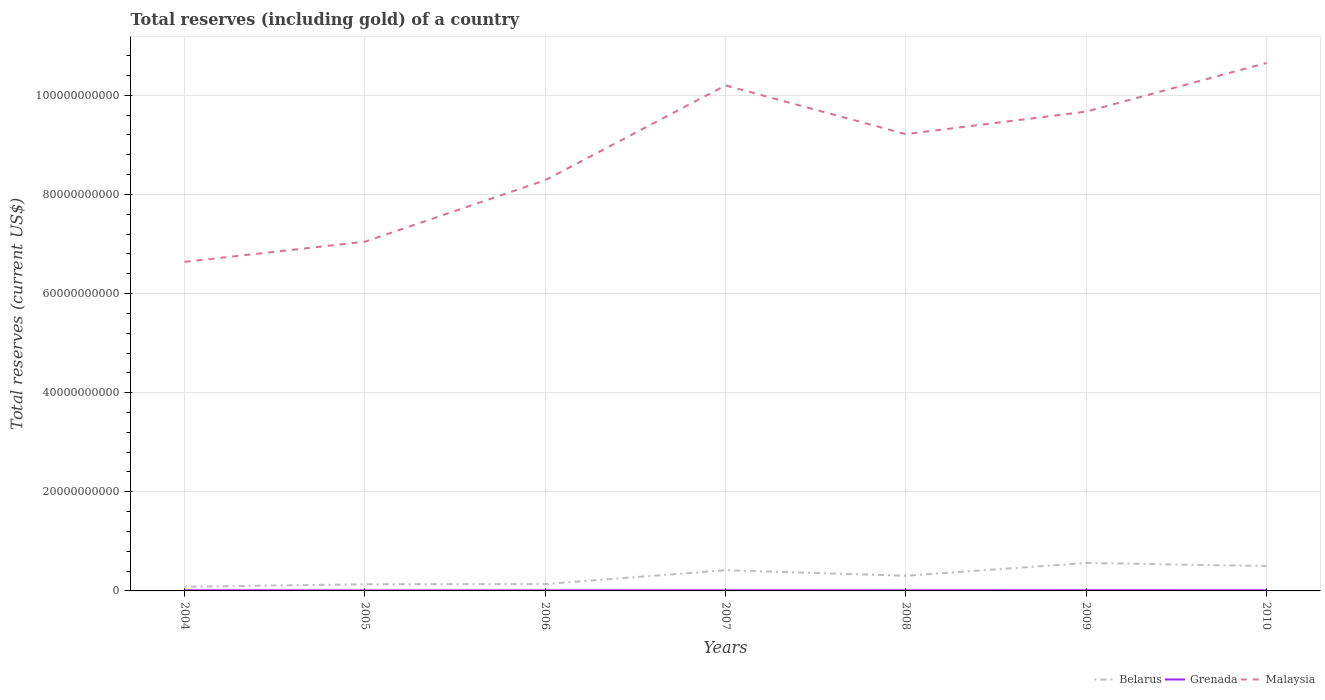How many different coloured lines are there?
Offer a terse response. 3. Across all years, what is the maximum total reserves (including gold) in Malaysia?
Your answer should be compact. 6.64e+1. What is the total total reserves (including gold) in Grenada in the graph?
Make the answer very short. -1.38e+07. What is the difference between the highest and the second highest total reserves (including gold) in Belarus?
Provide a short and direct response. 4.80e+09. What is the difference between the highest and the lowest total reserves (including gold) in Grenada?
Offer a terse response. 3. What is the difference between two consecutive major ticks on the Y-axis?
Keep it short and to the point. 2.00e+1. Does the graph contain grids?
Provide a short and direct response. Yes. How are the legend labels stacked?
Provide a short and direct response. Horizontal. What is the title of the graph?
Your response must be concise. Total reserves (including gold) of a country. Does "Paraguay" appear as one of the legend labels in the graph?
Your answer should be compact. No. What is the label or title of the Y-axis?
Your answer should be very brief. Total reserves (current US$). What is the Total reserves (current US$) of Belarus in 2004?
Make the answer very short. 8.37e+08. What is the Total reserves (current US$) of Grenada in 2004?
Ensure brevity in your answer.  1.22e+08. What is the Total reserves (current US$) in Malaysia in 2004?
Offer a terse response. 6.64e+1. What is the Total reserves (current US$) of Belarus in 2005?
Keep it short and to the point. 1.34e+09. What is the Total reserves (current US$) of Grenada in 2005?
Offer a terse response. 9.43e+07. What is the Total reserves (current US$) in Malaysia in 2005?
Provide a succinct answer. 7.05e+1. What is the Total reserves (current US$) in Belarus in 2006?
Give a very brief answer. 1.39e+09. What is the Total reserves (current US$) of Grenada in 2006?
Provide a succinct answer. 1.00e+08. What is the Total reserves (current US$) in Malaysia in 2006?
Your answer should be very brief. 8.29e+1. What is the Total reserves (current US$) in Belarus in 2007?
Offer a very short reply. 4.18e+09. What is the Total reserves (current US$) of Grenada in 2007?
Offer a terse response. 1.11e+08. What is the Total reserves (current US$) in Malaysia in 2007?
Make the answer very short. 1.02e+11. What is the Total reserves (current US$) of Belarus in 2008?
Give a very brief answer. 3.06e+09. What is the Total reserves (current US$) in Grenada in 2008?
Offer a terse response. 1.05e+08. What is the Total reserves (current US$) in Malaysia in 2008?
Give a very brief answer. 9.22e+1. What is the Total reserves (current US$) of Belarus in 2009?
Make the answer very short. 5.64e+09. What is the Total reserves (current US$) of Grenada in 2009?
Make the answer very short. 1.29e+08. What is the Total reserves (current US$) of Malaysia in 2009?
Offer a very short reply. 9.67e+1. What is the Total reserves (current US$) of Belarus in 2010?
Provide a succinct answer. 5.03e+09. What is the Total reserves (current US$) in Grenada in 2010?
Provide a short and direct response. 1.19e+08. What is the Total reserves (current US$) of Malaysia in 2010?
Offer a very short reply. 1.07e+11. Across all years, what is the maximum Total reserves (current US$) in Belarus?
Your answer should be very brief. 5.64e+09. Across all years, what is the maximum Total reserves (current US$) in Grenada?
Your response must be concise. 1.29e+08. Across all years, what is the maximum Total reserves (current US$) of Malaysia?
Make the answer very short. 1.07e+11. Across all years, what is the minimum Total reserves (current US$) of Belarus?
Your response must be concise. 8.37e+08. Across all years, what is the minimum Total reserves (current US$) of Grenada?
Give a very brief answer. 9.43e+07. Across all years, what is the minimum Total reserves (current US$) of Malaysia?
Your answer should be compact. 6.64e+1. What is the total Total reserves (current US$) in Belarus in the graph?
Your answer should be compact. 2.15e+1. What is the total Total reserves (current US$) of Grenada in the graph?
Give a very brief answer. 7.80e+08. What is the total Total reserves (current US$) in Malaysia in the graph?
Offer a very short reply. 6.17e+11. What is the difference between the Total reserves (current US$) of Belarus in 2004 and that in 2005?
Your answer should be compact. -5.05e+08. What is the difference between the Total reserves (current US$) in Grenada in 2004 and that in 2005?
Offer a very short reply. 2.75e+07. What is the difference between the Total reserves (current US$) of Malaysia in 2004 and that in 2005?
Provide a succinct answer. -4.06e+09. What is the difference between the Total reserves (current US$) of Belarus in 2004 and that in 2006?
Offer a very short reply. -5.49e+08. What is the difference between the Total reserves (current US$) in Grenada in 2004 and that in 2006?
Make the answer very short. 2.18e+07. What is the difference between the Total reserves (current US$) of Malaysia in 2004 and that in 2006?
Ensure brevity in your answer.  -1.65e+1. What is the difference between the Total reserves (current US$) of Belarus in 2004 and that in 2007?
Your answer should be compact. -3.34e+09. What is the difference between the Total reserves (current US$) of Grenada in 2004 and that in 2007?
Your response must be concise. 1.12e+07. What is the difference between the Total reserves (current US$) of Malaysia in 2004 and that in 2007?
Your answer should be compact. -3.56e+1. What is the difference between the Total reserves (current US$) of Belarus in 2004 and that in 2008?
Keep it short and to the point. -2.23e+09. What is the difference between the Total reserves (current US$) of Grenada in 2004 and that in 2008?
Make the answer very short. 1.64e+07. What is the difference between the Total reserves (current US$) in Malaysia in 2004 and that in 2008?
Give a very brief answer. -2.58e+1. What is the difference between the Total reserves (current US$) of Belarus in 2004 and that in 2009?
Keep it short and to the point. -4.80e+09. What is the difference between the Total reserves (current US$) in Grenada in 2004 and that in 2009?
Provide a short and direct response. -7.35e+06. What is the difference between the Total reserves (current US$) of Malaysia in 2004 and that in 2009?
Your answer should be compact. -3.03e+1. What is the difference between the Total reserves (current US$) in Belarus in 2004 and that in 2010?
Your answer should be compact. -4.19e+09. What is the difference between the Total reserves (current US$) of Grenada in 2004 and that in 2010?
Ensure brevity in your answer.  2.57e+06. What is the difference between the Total reserves (current US$) of Malaysia in 2004 and that in 2010?
Offer a very short reply. -4.01e+1. What is the difference between the Total reserves (current US$) in Belarus in 2005 and that in 2006?
Your answer should be very brief. -4.46e+07. What is the difference between the Total reserves (current US$) of Grenada in 2005 and that in 2006?
Offer a terse response. -5.71e+06. What is the difference between the Total reserves (current US$) in Malaysia in 2005 and that in 2006?
Offer a very short reply. -1.24e+1. What is the difference between the Total reserves (current US$) of Belarus in 2005 and that in 2007?
Ensure brevity in your answer.  -2.84e+09. What is the difference between the Total reserves (current US$) of Grenada in 2005 and that in 2007?
Your response must be concise. -1.63e+07. What is the difference between the Total reserves (current US$) of Malaysia in 2005 and that in 2007?
Your answer should be compact. -3.15e+1. What is the difference between the Total reserves (current US$) in Belarus in 2005 and that in 2008?
Offer a terse response. -1.72e+09. What is the difference between the Total reserves (current US$) in Grenada in 2005 and that in 2008?
Your response must be concise. -1.11e+07. What is the difference between the Total reserves (current US$) in Malaysia in 2005 and that in 2008?
Provide a succinct answer. -2.17e+1. What is the difference between the Total reserves (current US$) in Belarus in 2005 and that in 2009?
Offer a terse response. -4.30e+09. What is the difference between the Total reserves (current US$) in Grenada in 2005 and that in 2009?
Ensure brevity in your answer.  -3.48e+07. What is the difference between the Total reserves (current US$) of Malaysia in 2005 and that in 2009?
Your answer should be very brief. -2.62e+1. What is the difference between the Total reserves (current US$) of Belarus in 2005 and that in 2010?
Make the answer very short. -3.68e+09. What is the difference between the Total reserves (current US$) in Grenada in 2005 and that in 2010?
Your answer should be compact. -2.49e+07. What is the difference between the Total reserves (current US$) in Malaysia in 2005 and that in 2010?
Ensure brevity in your answer.  -3.61e+1. What is the difference between the Total reserves (current US$) of Belarus in 2006 and that in 2007?
Give a very brief answer. -2.79e+09. What is the difference between the Total reserves (current US$) of Grenada in 2006 and that in 2007?
Provide a short and direct response. -1.06e+07. What is the difference between the Total reserves (current US$) of Malaysia in 2006 and that in 2007?
Give a very brief answer. -1.91e+1. What is the difference between the Total reserves (current US$) of Belarus in 2006 and that in 2008?
Offer a very short reply. -1.68e+09. What is the difference between the Total reserves (current US$) in Grenada in 2006 and that in 2008?
Provide a short and direct response. -5.38e+06. What is the difference between the Total reserves (current US$) of Malaysia in 2006 and that in 2008?
Keep it short and to the point. -9.29e+09. What is the difference between the Total reserves (current US$) of Belarus in 2006 and that in 2009?
Your answer should be compact. -4.25e+09. What is the difference between the Total reserves (current US$) in Grenada in 2006 and that in 2009?
Your answer should be compact. -2.91e+07. What is the difference between the Total reserves (current US$) of Malaysia in 2006 and that in 2009?
Keep it short and to the point. -1.38e+1. What is the difference between the Total reserves (current US$) in Belarus in 2006 and that in 2010?
Offer a terse response. -3.64e+09. What is the difference between the Total reserves (current US$) in Grenada in 2006 and that in 2010?
Offer a terse response. -1.92e+07. What is the difference between the Total reserves (current US$) of Malaysia in 2006 and that in 2010?
Provide a short and direct response. -2.37e+1. What is the difference between the Total reserves (current US$) in Belarus in 2007 and that in 2008?
Provide a succinct answer. 1.12e+09. What is the difference between the Total reserves (current US$) of Grenada in 2007 and that in 2008?
Your answer should be very brief. 5.23e+06. What is the difference between the Total reserves (current US$) of Malaysia in 2007 and that in 2008?
Give a very brief answer. 9.83e+09. What is the difference between the Total reserves (current US$) in Belarus in 2007 and that in 2009?
Your answer should be compact. -1.46e+09. What is the difference between the Total reserves (current US$) in Grenada in 2007 and that in 2009?
Offer a terse response. -1.85e+07. What is the difference between the Total reserves (current US$) in Malaysia in 2007 and that in 2009?
Ensure brevity in your answer.  5.29e+09. What is the difference between the Total reserves (current US$) of Belarus in 2007 and that in 2010?
Your answer should be very brief. -8.47e+08. What is the difference between the Total reserves (current US$) in Grenada in 2007 and that in 2010?
Make the answer very short. -8.59e+06. What is the difference between the Total reserves (current US$) in Malaysia in 2007 and that in 2010?
Offer a terse response. -4.53e+09. What is the difference between the Total reserves (current US$) in Belarus in 2008 and that in 2009?
Provide a succinct answer. -2.58e+09. What is the difference between the Total reserves (current US$) in Grenada in 2008 and that in 2009?
Give a very brief answer. -2.37e+07. What is the difference between the Total reserves (current US$) of Malaysia in 2008 and that in 2009?
Your response must be concise. -4.54e+09. What is the difference between the Total reserves (current US$) in Belarus in 2008 and that in 2010?
Your answer should be compact. -1.96e+09. What is the difference between the Total reserves (current US$) of Grenada in 2008 and that in 2010?
Provide a succinct answer. -1.38e+07. What is the difference between the Total reserves (current US$) of Malaysia in 2008 and that in 2010?
Give a very brief answer. -1.44e+1. What is the difference between the Total reserves (current US$) in Belarus in 2009 and that in 2010?
Your answer should be very brief. 6.15e+08. What is the difference between the Total reserves (current US$) in Grenada in 2009 and that in 2010?
Keep it short and to the point. 9.92e+06. What is the difference between the Total reserves (current US$) in Malaysia in 2009 and that in 2010?
Ensure brevity in your answer.  -9.82e+09. What is the difference between the Total reserves (current US$) of Belarus in 2004 and the Total reserves (current US$) of Grenada in 2005?
Your answer should be compact. 7.43e+08. What is the difference between the Total reserves (current US$) of Belarus in 2004 and the Total reserves (current US$) of Malaysia in 2005?
Give a very brief answer. -6.96e+1. What is the difference between the Total reserves (current US$) in Grenada in 2004 and the Total reserves (current US$) in Malaysia in 2005?
Give a very brief answer. -7.03e+1. What is the difference between the Total reserves (current US$) in Belarus in 2004 and the Total reserves (current US$) in Grenada in 2006?
Give a very brief answer. 7.37e+08. What is the difference between the Total reserves (current US$) in Belarus in 2004 and the Total reserves (current US$) in Malaysia in 2006?
Your answer should be very brief. -8.20e+1. What is the difference between the Total reserves (current US$) of Grenada in 2004 and the Total reserves (current US$) of Malaysia in 2006?
Give a very brief answer. -8.28e+1. What is the difference between the Total reserves (current US$) in Belarus in 2004 and the Total reserves (current US$) in Grenada in 2007?
Keep it short and to the point. 7.26e+08. What is the difference between the Total reserves (current US$) in Belarus in 2004 and the Total reserves (current US$) in Malaysia in 2007?
Offer a terse response. -1.01e+11. What is the difference between the Total reserves (current US$) in Grenada in 2004 and the Total reserves (current US$) in Malaysia in 2007?
Offer a terse response. -1.02e+11. What is the difference between the Total reserves (current US$) in Belarus in 2004 and the Total reserves (current US$) in Grenada in 2008?
Offer a very short reply. 7.32e+08. What is the difference between the Total reserves (current US$) of Belarus in 2004 and the Total reserves (current US$) of Malaysia in 2008?
Offer a very short reply. -9.13e+1. What is the difference between the Total reserves (current US$) of Grenada in 2004 and the Total reserves (current US$) of Malaysia in 2008?
Your answer should be compact. -9.20e+1. What is the difference between the Total reserves (current US$) of Belarus in 2004 and the Total reserves (current US$) of Grenada in 2009?
Ensure brevity in your answer.  7.08e+08. What is the difference between the Total reserves (current US$) in Belarus in 2004 and the Total reserves (current US$) in Malaysia in 2009?
Provide a succinct answer. -9.59e+1. What is the difference between the Total reserves (current US$) in Grenada in 2004 and the Total reserves (current US$) in Malaysia in 2009?
Ensure brevity in your answer.  -9.66e+1. What is the difference between the Total reserves (current US$) of Belarus in 2004 and the Total reserves (current US$) of Grenada in 2010?
Make the answer very short. 7.18e+08. What is the difference between the Total reserves (current US$) of Belarus in 2004 and the Total reserves (current US$) of Malaysia in 2010?
Provide a succinct answer. -1.06e+11. What is the difference between the Total reserves (current US$) in Grenada in 2004 and the Total reserves (current US$) in Malaysia in 2010?
Offer a very short reply. -1.06e+11. What is the difference between the Total reserves (current US$) in Belarus in 2005 and the Total reserves (current US$) in Grenada in 2006?
Your answer should be very brief. 1.24e+09. What is the difference between the Total reserves (current US$) of Belarus in 2005 and the Total reserves (current US$) of Malaysia in 2006?
Provide a succinct answer. -8.15e+1. What is the difference between the Total reserves (current US$) of Grenada in 2005 and the Total reserves (current US$) of Malaysia in 2006?
Offer a terse response. -8.28e+1. What is the difference between the Total reserves (current US$) in Belarus in 2005 and the Total reserves (current US$) in Grenada in 2007?
Offer a terse response. 1.23e+09. What is the difference between the Total reserves (current US$) of Belarus in 2005 and the Total reserves (current US$) of Malaysia in 2007?
Offer a very short reply. -1.01e+11. What is the difference between the Total reserves (current US$) of Grenada in 2005 and the Total reserves (current US$) of Malaysia in 2007?
Ensure brevity in your answer.  -1.02e+11. What is the difference between the Total reserves (current US$) in Belarus in 2005 and the Total reserves (current US$) in Grenada in 2008?
Keep it short and to the point. 1.24e+09. What is the difference between the Total reserves (current US$) of Belarus in 2005 and the Total reserves (current US$) of Malaysia in 2008?
Offer a terse response. -9.08e+1. What is the difference between the Total reserves (current US$) in Grenada in 2005 and the Total reserves (current US$) in Malaysia in 2008?
Provide a short and direct response. -9.21e+1. What is the difference between the Total reserves (current US$) of Belarus in 2005 and the Total reserves (current US$) of Grenada in 2009?
Provide a succinct answer. 1.21e+09. What is the difference between the Total reserves (current US$) of Belarus in 2005 and the Total reserves (current US$) of Malaysia in 2009?
Offer a terse response. -9.54e+1. What is the difference between the Total reserves (current US$) in Grenada in 2005 and the Total reserves (current US$) in Malaysia in 2009?
Your answer should be compact. -9.66e+1. What is the difference between the Total reserves (current US$) of Belarus in 2005 and the Total reserves (current US$) of Grenada in 2010?
Keep it short and to the point. 1.22e+09. What is the difference between the Total reserves (current US$) in Belarus in 2005 and the Total reserves (current US$) in Malaysia in 2010?
Your answer should be very brief. -1.05e+11. What is the difference between the Total reserves (current US$) of Grenada in 2005 and the Total reserves (current US$) of Malaysia in 2010?
Keep it short and to the point. -1.06e+11. What is the difference between the Total reserves (current US$) of Belarus in 2006 and the Total reserves (current US$) of Grenada in 2007?
Keep it short and to the point. 1.28e+09. What is the difference between the Total reserves (current US$) in Belarus in 2006 and the Total reserves (current US$) in Malaysia in 2007?
Give a very brief answer. -1.01e+11. What is the difference between the Total reserves (current US$) in Grenada in 2006 and the Total reserves (current US$) in Malaysia in 2007?
Your answer should be very brief. -1.02e+11. What is the difference between the Total reserves (current US$) in Belarus in 2006 and the Total reserves (current US$) in Grenada in 2008?
Keep it short and to the point. 1.28e+09. What is the difference between the Total reserves (current US$) in Belarus in 2006 and the Total reserves (current US$) in Malaysia in 2008?
Give a very brief answer. -9.08e+1. What is the difference between the Total reserves (current US$) in Grenada in 2006 and the Total reserves (current US$) in Malaysia in 2008?
Provide a short and direct response. -9.21e+1. What is the difference between the Total reserves (current US$) in Belarus in 2006 and the Total reserves (current US$) in Grenada in 2009?
Keep it short and to the point. 1.26e+09. What is the difference between the Total reserves (current US$) of Belarus in 2006 and the Total reserves (current US$) of Malaysia in 2009?
Provide a succinct answer. -9.53e+1. What is the difference between the Total reserves (current US$) in Grenada in 2006 and the Total reserves (current US$) in Malaysia in 2009?
Ensure brevity in your answer.  -9.66e+1. What is the difference between the Total reserves (current US$) of Belarus in 2006 and the Total reserves (current US$) of Grenada in 2010?
Your answer should be compact. 1.27e+09. What is the difference between the Total reserves (current US$) in Belarus in 2006 and the Total reserves (current US$) in Malaysia in 2010?
Your answer should be very brief. -1.05e+11. What is the difference between the Total reserves (current US$) of Grenada in 2006 and the Total reserves (current US$) of Malaysia in 2010?
Your response must be concise. -1.06e+11. What is the difference between the Total reserves (current US$) of Belarus in 2007 and the Total reserves (current US$) of Grenada in 2008?
Offer a terse response. 4.07e+09. What is the difference between the Total reserves (current US$) of Belarus in 2007 and the Total reserves (current US$) of Malaysia in 2008?
Ensure brevity in your answer.  -8.80e+1. What is the difference between the Total reserves (current US$) of Grenada in 2007 and the Total reserves (current US$) of Malaysia in 2008?
Your answer should be very brief. -9.21e+1. What is the difference between the Total reserves (current US$) of Belarus in 2007 and the Total reserves (current US$) of Grenada in 2009?
Your response must be concise. 4.05e+09. What is the difference between the Total reserves (current US$) of Belarus in 2007 and the Total reserves (current US$) of Malaysia in 2009?
Offer a very short reply. -9.25e+1. What is the difference between the Total reserves (current US$) in Grenada in 2007 and the Total reserves (current US$) in Malaysia in 2009?
Your response must be concise. -9.66e+1. What is the difference between the Total reserves (current US$) in Belarus in 2007 and the Total reserves (current US$) in Grenada in 2010?
Ensure brevity in your answer.  4.06e+09. What is the difference between the Total reserves (current US$) in Belarus in 2007 and the Total reserves (current US$) in Malaysia in 2010?
Give a very brief answer. -1.02e+11. What is the difference between the Total reserves (current US$) in Grenada in 2007 and the Total reserves (current US$) in Malaysia in 2010?
Provide a succinct answer. -1.06e+11. What is the difference between the Total reserves (current US$) of Belarus in 2008 and the Total reserves (current US$) of Grenada in 2009?
Your response must be concise. 2.93e+09. What is the difference between the Total reserves (current US$) of Belarus in 2008 and the Total reserves (current US$) of Malaysia in 2009?
Ensure brevity in your answer.  -9.36e+1. What is the difference between the Total reserves (current US$) of Grenada in 2008 and the Total reserves (current US$) of Malaysia in 2009?
Offer a terse response. -9.66e+1. What is the difference between the Total reserves (current US$) in Belarus in 2008 and the Total reserves (current US$) in Grenada in 2010?
Ensure brevity in your answer.  2.94e+09. What is the difference between the Total reserves (current US$) of Belarus in 2008 and the Total reserves (current US$) of Malaysia in 2010?
Provide a succinct answer. -1.03e+11. What is the difference between the Total reserves (current US$) in Grenada in 2008 and the Total reserves (current US$) in Malaysia in 2010?
Keep it short and to the point. -1.06e+11. What is the difference between the Total reserves (current US$) of Belarus in 2009 and the Total reserves (current US$) of Grenada in 2010?
Keep it short and to the point. 5.52e+09. What is the difference between the Total reserves (current US$) of Belarus in 2009 and the Total reserves (current US$) of Malaysia in 2010?
Keep it short and to the point. -1.01e+11. What is the difference between the Total reserves (current US$) of Grenada in 2009 and the Total reserves (current US$) of Malaysia in 2010?
Offer a very short reply. -1.06e+11. What is the average Total reserves (current US$) in Belarus per year?
Ensure brevity in your answer.  3.07e+09. What is the average Total reserves (current US$) in Grenada per year?
Provide a short and direct response. 1.11e+08. What is the average Total reserves (current US$) of Malaysia per year?
Your answer should be compact. 8.82e+1. In the year 2004, what is the difference between the Total reserves (current US$) in Belarus and Total reserves (current US$) in Grenada?
Ensure brevity in your answer.  7.15e+08. In the year 2004, what is the difference between the Total reserves (current US$) in Belarus and Total reserves (current US$) in Malaysia?
Provide a succinct answer. -6.56e+1. In the year 2004, what is the difference between the Total reserves (current US$) of Grenada and Total reserves (current US$) of Malaysia?
Your response must be concise. -6.63e+1. In the year 2005, what is the difference between the Total reserves (current US$) in Belarus and Total reserves (current US$) in Grenada?
Your answer should be compact. 1.25e+09. In the year 2005, what is the difference between the Total reserves (current US$) in Belarus and Total reserves (current US$) in Malaysia?
Make the answer very short. -6.91e+1. In the year 2005, what is the difference between the Total reserves (current US$) in Grenada and Total reserves (current US$) in Malaysia?
Keep it short and to the point. -7.04e+1. In the year 2006, what is the difference between the Total reserves (current US$) of Belarus and Total reserves (current US$) of Grenada?
Your answer should be compact. 1.29e+09. In the year 2006, what is the difference between the Total reserves (current US$) in Belarus and Total reserves (current US$) in Malaysia?
Your response must be concise. -8.15e+1. In the year 2006, what is the difference between the Total reserves (current US$) of Grenada and Total reserves (current US$) of Malaysia?
Your answer should be very brief. -8.28e+1. In the year 2007, what is the difference between the Total reserves (current US$) of Belarus and Total reserves (current US$) of Grenada?
Give a very brief answer. 4.07e+09. In the year 2007, what is the difference between the Total reserves (current US$) in Belarus and Total reserves (current US$) in Malaysia?
Provide a succinct answer. -9.78e+1. In the year 2007, what is the difference between the Total reserves (current US$) of Grenada and Total reserves (current US$) of Malaysia?
Offer a terse response. -1.02e+11. In the year 2008, what is the difference between the Total reserves (current US$) of Belarus and Total reserves (current US$) of Grenada?
Provide a short and direct response. 2.96e+09. In the year 2008, what is the difference between the Total reserves (current US$) in Belarus and Total reserves (current US$) in Malaysia?
Your response must be concise. -8.91e+1. In the year 2008, what is the difference between the Total reserves (current US$) of Grenada and Total reserves (current US$) of Malaysia?
Provide a short and direct response. -9.21e+1. In the year 2009, what is the difference between the Total reserves (current US$) in Belarus and Total reserves (current US$) in Grenada?
Provide a succinct answer. 5.51e+09. In the year 2009, what is the difference between the Total reserves (current US$) of Belarus and Total reserves (current US$) of Malaysia?
Your answer should be very brief. -9.11e+1. In the year 2009, what is the difference between the Total reserves (current US$) in Grenada and Total reserves (current US$) in Malaysia?
Give a very brief answer. -9.66e+1. In the year 2010, what is the difference between the Total reserves (current US$) in Belarus and Total reserves (current US$) in Grenada?
Offer a very short reply. 4.91e+09. In the year 2010, what is the difference between the Total reserves (current US$) of Belarus and Total reserves (current US$) of Malaysia?
Provide a short and direct response. -1.02e+11. In the year 2010, what is the difference between the Total reserves (current US$) of Grenada and Total reserves (current US$) of Malaysia?
Offer a very short reply. -1.06e+11. What is the ratio of the Total reserves (current US$) in Belarus in 2004 to that in 2005?
Keep it short and to the point. 0.62. What is the ratio of the Total reserves (current US$) of Grenada in 2004 to that in 2005?
Keep it short and to the point. 1.29. What is the ratio of the Total reserves (current US$) of Malaysia in 2004 to that in 2005?
Your response must be concise. 0.94. What is the ratio of the Total reserves (current US$) in Belarus in 2004 to that in 2006?
Offer a very short reply. 0.6. What is the ratio of the Total reserves (current US$) of Grenada in 2004 to that in 2006?
Your response must be concise. 1.22. What is the ratio of the Total reserves (current US$) in Malaysia in 2004 to that in 2006?
Ensure brevity in your answer.  0.8. What is the ratio of the Total reserves (current US$) in Belarus in 2004 to that in 2007?
Your answer should be very brief. 0.2. What is the ratio of the Total reserves (current US$) in Grenada in 2004 to that in 2007?
Provide a succinct answer. 1.1. What is the ratio of the Total reserves (current US$) in Malaysia in 2004 to that in 2007?
Keep it short and to the point. 0.65. What is the ratio of the Total reserves (current US$) of Belarus in 2004 to that in 2008?
Provide a short and direct response. 0.27. What is the ratio of the Total reserves (current US$) of Grenada in 2004 to that in 2008?
Your response must be concise. 1.16. What is the ratio of the Total reserves (current US$) of Malaysia in 2004 to that in 2008?
Provide a succinct answer. 0.72. What is the ratio of the Total reserves (current US$) of Belarus in 2004 to that in 2009?
Your answer should be very brief. 0.15. What is the ratio of the Total reserves (current US$) of Grenada in 2004 to that in 2009?
Your answer should be very brief. 0.94. What is the ratio of the Total reserves (current US$) in Malaysia in 2004 to that in 2009?
Your answer should be compact. 0.69. What is the ratio of the Total reserves (current US$) in Belarus in 2004 to that in 2010?
Your answer should be very brief. 0.17. What is the ratio of the Total reserves (current US$) in Grenada in 2004 to that in 2010?
Give a very brief answer. 1.02. What is the ratio of the Total reserves (current US$) in Malaysia in 2004 to that in 2010?
Provide a succinct answer. 0.62. What is the ratio of the Total reserves (current US$) of Belarus in 2005 to that in 2006?
Your answer should be very brief. 0.97. What is the ratio of the Total reserves (current US$) in Grenada in 2005 to that in 2006?
Provide a succinct answer. 0.94. What is the ratio of the Total reserves (current US$) of Malaysia in 2005 to that in 2006?
Offer a terse response. 0.85. What is the ratio of the Total reserves (current US$) in Belarus in 2005 to that in 2007?
Offer a terse response. 0.32. What is the ratio of the Total reserves (current US$) of Grenada in 2005 to that in 2007?
Your response must be concise. 0.85. What is the ratio of the Total reserves (current US$) of Malaysia in 2005 to that in 2007?
Your answer should be very brief. 0.69. What is the ratio of the Total reserves (current US$) in Belarus in 2005 to that in 2008?
Offer a terse response. 0.44. What is the ratio of the Total reserves (current US$) in Grenada in 2005 to that in 2008?
Provide a short and direct response. 0.89. What is the ratio of the Total reserves (current US$) in Malaysia in 2005 to that in 2008?
Give a very brief answer. 0.76. What is the ratio of the Total reserves (current US$) in Belarus in 2005 to that in 2009?
Give a very brief answer. 0.24. What is the ratio of the Total reserves (current US$) in Grenada in 2005 to that in 2009?
Give a very brief answer. 0.73. What is the ratio of the Total reserves (current US$) in Malaysia in 2005 to that in 2009?
Provide a succinct answer. 0.73. What is the ratio of the Total reserves (current US$) in Belarus in 2005 to that in 2010?
Offer a terse response. 0.27. What is the ratio of the Total reserves (current US$) in Grenada in 2005 to that in 2010?
Your answer should be compact. 0.79. What is the ratio of the Total reserves (current US$) in Malaysia in 2005 to that in 2010?
Your answer should be compact. 0.66. What is the ratio of the Total reserves (current US$) of Belarus in 2006 to that in 2007?
Keep it short and to the point. 0.33. What is the ratio of the Total reserves (current US$) in Grenada in 2006 to that in 2007?
Make the answer very short. 0.9. What is the ratio of the Total reserves (current US$) in Malaysia in 2006 to that in 2007?
Keep it short and to the point. 0.81. What is the ratio of the Total reserves (current US$) in Belarus in 2006 to that in 2008?
Your response must be concise. 0.45. What is the ratio of the Total reserves (current US$) of Grenada in 2006 to that in 2008?
Offer a very short reply. 0.95. What is the ratio of the Total reserves (current US$) in Malaysia in 2006 to that in 2008?
Provide a succinct answer. 0.9. What is the ratio of the Total reserves (current US$) of Belarus in 2006 to that in 2009?
Your answer should be compact. 0.25. What is the ratio of the Total reserves (current US$) of Grenada in 2006 to that in 2009?
Give a very brief answer. 0.77. What is the ratio of the Total reserves (current US$) in Malaysia in 2006 to that in 2009?
Provide a short and direct response. 0.86. What is the ratio of the Total reserves (current US$) of Belarus in 2006 to that in 2010?
Your answer should be compact. 0.28. What is the ratio of the Total reserves (current US$) of Grenada in 2006 to that in 2010?
Keep it short and to the point. 0.84. What is the ratio of the Total reserves (current US$) in Malaysia in 2006 to that in 2010?
Offer a terse response. 0.78. What is the ratio of the Total reserves (current US$) in Belarus in 2007 to that in 2008?
Offer a terse response. 1.36. What is the ratio of the Total reserves (current US$) of Grenada in 2007 to that in 2008?
Keep it short and to the point. 1.05. What is the ratio of the Total reserves (current US$) in Malaysia in 2007 to that in 2008?
Your response must be concise. 1.11. What is the ratio of the Total reserves (current US$) in Belarus in 2007 to that in 2009?
Offer a terse response. 0.74. What is the ratio of the Total reserves (current US$) in Grenada in 2007 to that in 2009?
Offer a terse response. 0.86. What is the ratio of the Total reserves (current US$) of Malaysia in 2007 to that in 2009?
Keep it short and to the point. 1.05. What is the ratio of the Total reserves (current US$) in Belarus in 2007 to that in 2010?
Keep it short and to the point. 0.83. What is the ratio of the Total reserves (current US$) in Grenada in 2007 to that in 2010?
Make the answer very short. 0.93. What is the ratio of the Total reserves (current US$) of Malaysia in 2007 to that in 2010?
Give a very brief answer. 0.96. What is the ratio of the Total reserves (current US$) of Belarus in 2008 to that in 2009?
Your answer should be compact. 0.54. What is the ratio of the Total reserves (current US$) of Grenada in 2008 to that in 2009?
Keep it short and to the point. 0.82. What is the ratio of the Total reserves (current US$) of Malaysia in 2008 to that in 2009?
Offer a terse response. 0.95. What is the ratio of the Total reserves (current US$) of Belarus in 2008 to that in 2010?
Ensure brevity in your answer.  0.61. What is the ratio of the Total reserves (current US$) of Grenada in 2008 to that in 2010?
Offer a terse response. 0.88. What is the ratio of the Total reserves (current US$) of Malaysia in 2008 to that in 2010?
Your answer should be compact. 0.87. What is the ratio of the Total reserves (current US$) in Belarus in 2009 to that in 2010?
Your response must be concise. 1.12. What is the ratio of the Total reserves (current US$) of Malaysia in 2009 to that in 2010?
Keep it short and to the point. 0.91. What is the difference between the highest and the second highest Total reserves (current US$) of Belarus?
Offer a terse response. 6.15e+08. What is the difference between the highest and the second highest Total reserves (current US$) of Grenada?
Give a very brief answer. 7.35e+06. What is the difference between the highest and the second highest Total reserves (current US$) of Malaysia?
Provide a succinct answer. 4.53e+09. What is the difference between the highest and the lowest Total reserves (current US$) in Belarus?
Your response must be concise. 4.80e+09. What is the difference between the highest and the lowest Total reserves (current US$) of Grenada?
Offer a very short reply. 3.48e+07. What is the difference between the highest and the lowest Total reserves (current US$) of Malaysia?
Your response must be concise. 4.01e+1. 